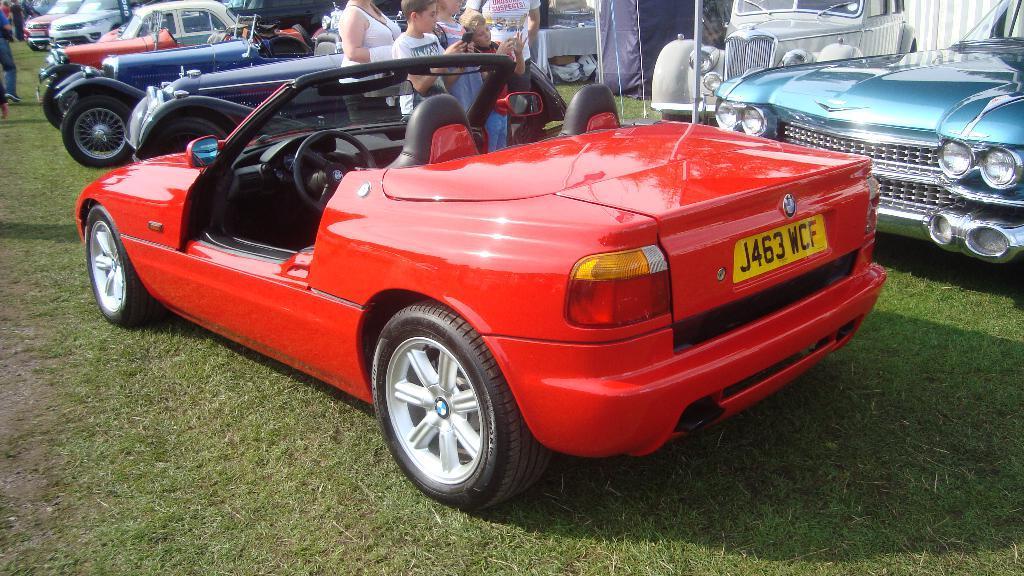Could you give a brief overview of what you see in this image? There is a grassy land at the bottom of this image and there are some cars parked at the top of this image. there are some persons standing at the top middle of this image and top left corner of this image as well. 